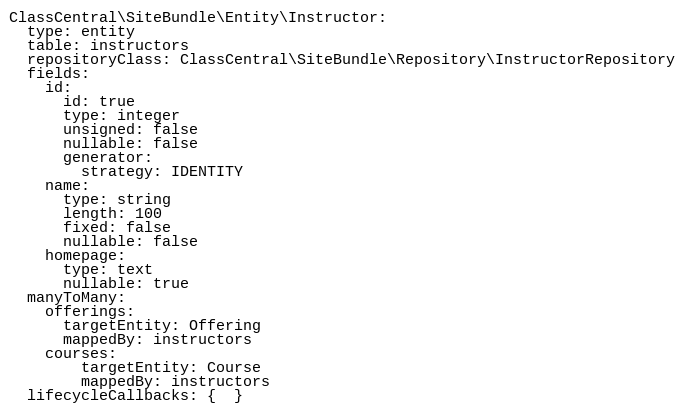Convert code to text. <code><loc_0><loc_0><loc_500><loc_500><_YAML_>ClassCentral\SiteBundle\Entity\Instructor:
  type: entity
  table: instructors
  repositoryClass: ClassCentral\SiteBundle\Repository\InstructorRepository
  fields:
    id:
      id: true
      type: integer
      unsigned: false
      nullable: false
      generator:
        strategy: IDENTITY
    name:
      type: string
      length: 100
      fixed: false
      nullable: false
    homepage:
      type: text
      nullable: true  
  manyToMany:
    offerings:
      targetEntity: Offering
      mappedBy: instructors
    courses:
        targetEntity: Course
        mappedBy: instructors
  lifecycleCallbacks: {  }
</code> 